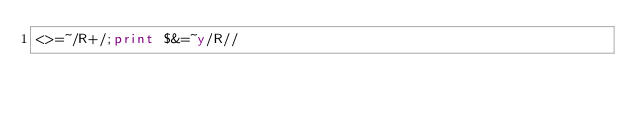<code> <loc_0><loc_0><loc_500><loc_500><_Perl_><>=~/R+/;print $&=~y/R//</code> 